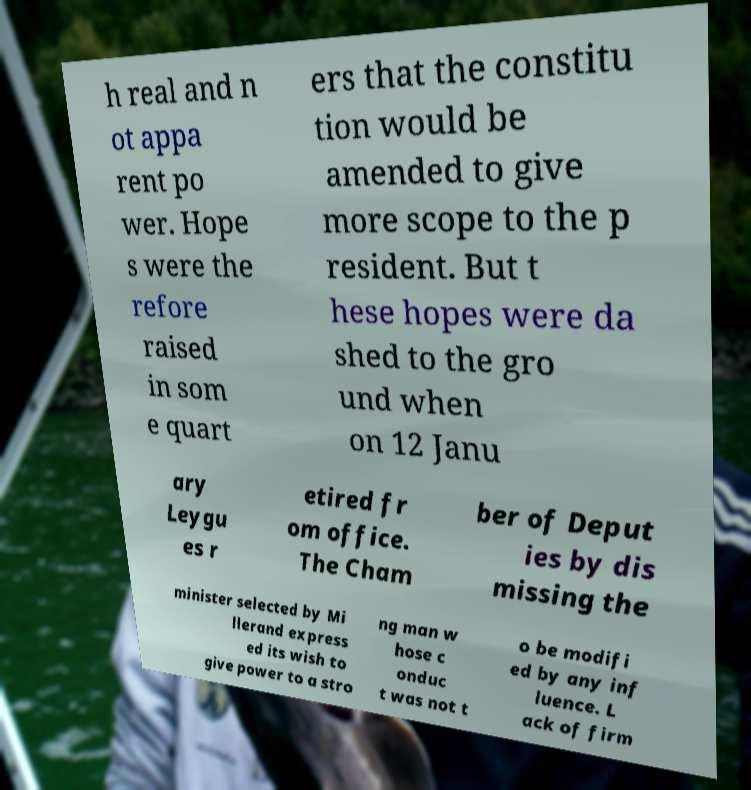For documentation purposes, I need the text within this image transcribed. Could you provide that? h real and n ot appa rent po wer. Hope s were the refore raised in som e quart ers that the constitu tion would be amended to give more scope to the p resident. But t hese hopes were da shed to the gro und when on 12 Janu ary Leygu es r etired fr om office. The Cham ber of Deput ies by dis missing the minister selected by Mi llerand express ed its wish to give power to a stro ng man w hose c onduc t was not t o be modifi ed by any inf luence. L ack of firm 